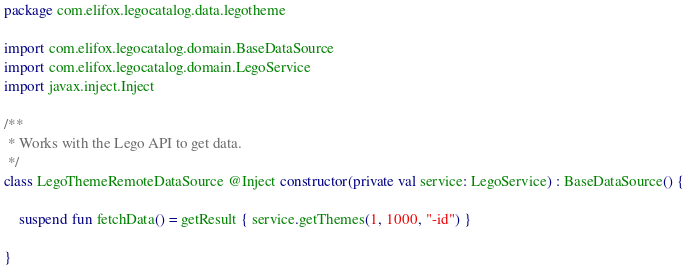Convert code to text. <code><loc_0><loc_0><loc_500><loc_500><_Kotlin_>package com.elifox.legocatalog.data.legotheme

import com.elifox.legocatalog.domain.BaseDataSource
import com.elifox.legocatalog.domain.LegoService
import javax.inject.Inject

/**
 * Works with the Lego API to get data.
 */
class LegoThemeRemoteDataSource @Inject constructor(private val service: LegoService) : BaseDataSource() {

    suspend fun fetchData() = getResult { service.getThemes(1, 1000, "-id") }

}
</code> 